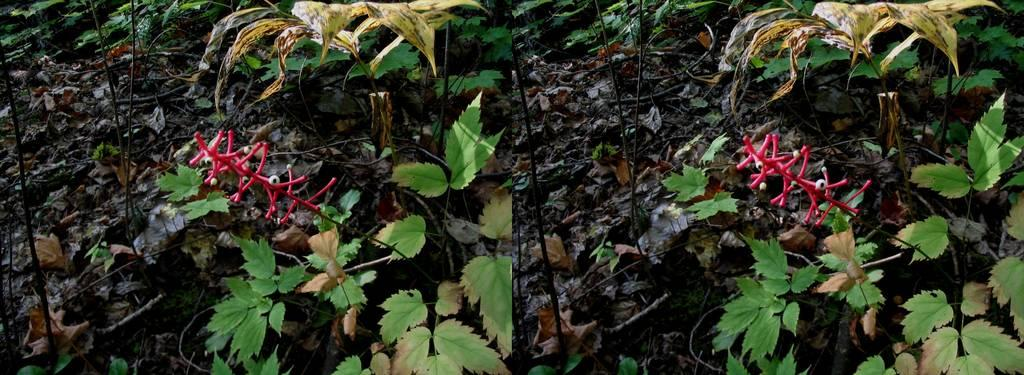What type of artwork is the image? The image is a collage. What type of natural elements are included in the collage? There are plants in the image. What additional elements can be seen in the collage? There are dry leaves in the image. What type of hammer is being used to collect the profit in the image? There is no hammer or mention of profit in the image; it features a collage with plants and dry leaves. 